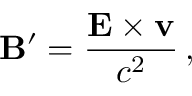<formula> <loc_0><loc_0><loc_500><loc_500>B ^ { \prime } = { \frac { E \times v } { c ^ { 2 } } } \, ,</formula> 